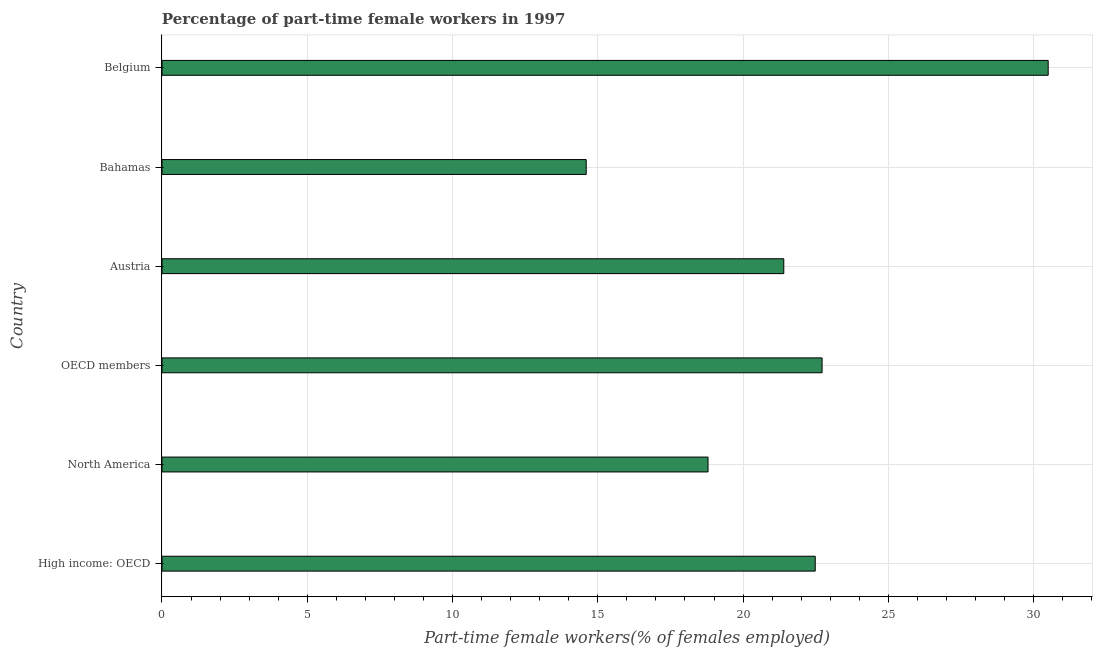Does the graph contain grids?
Give a very brief answer. Yes. What is the title of the graph?
Offer a terse response. Percentage of part-time female workers in 1997. What is the label or title of the X-axis?
Your answer should be very brief. Part-time female workers(% of females employed). What is the percentage of part-time female workers in North America?
Offer a terse response. 18.79. Across all countries, what is the maximum percentage of part-time female workers?
Provide a succinct answer. 30.5. Across all countries, what is the minimum percentage of part-time female workers?
Keep it short and to the point. 14.6. In which country was the percentage of part-time female workers minimum?
Your answer should be compact. Bahamas. What is the sum of the percentage of part-time female workers?
Your answer should be compact. 130.49. What is the difference between the percentage of part-time female workers in Bahamas and North America?
Provide a succinct answer. -4.19. What is the average percentage of part-time female workers per country?
Make the answer very short. 21.75. What is the median percentage of part-time female workers?
Make the answer very short. 21.94. What is the ratio of the percentage of part-time female workers in North America to that in OECD members?
Your answer should be very brief. 0.83. What is the difference between the highest and the second highest percentage of part-time female workers?
Your answer should be compact. 7.78. How many bars are there?
Give a very brief answer. 6. Are all the bars in the graph horizontal?
Your answer should be compact. Yes. How many countries are there in the graph?
Provide a succinct answer. 6. What is the difference between two consecutive major ticks on the X-axis?
Ensure brevity in your answer.  5. Are the values on the major ticks of X-axis written in scientific E-notation?
Ensure brevity in your answer.  No. What is the Part-time female workers(% of females employed) of High income: OECD?
Your response must be concise. 22.48. What is the Part-time female workers(% of females employed) in North America?
Offer a very short reply. 18.79. What is the Part-time female workers(% of females employed) of OECD members?
Give a very brief answer. 22.72. What is the Part-time female workers(% of females employed) in Austria?
Your response must be concise. 21.4. What is the Part-time female workers(% of females employed) in Bahamas?
Provide a succinct answer. 14.6. What is the Part-time female workers(% of females employed) in Belgium?
Offer a very short reply. 30.5. What is the difference between the Part-time female workers(% of females employed) in High income: OECD and North America?
Your answer should be very brief. 3.69. What is the difference between the Part-time female workers(% of females employed) in High income: OECD and OECD members?
Offer a very short reply. -0.24. What is the difference between the Part-time female workers(% of females employed) in High income: OECD and Austria?
Give a very brief answer. 1.08. What is the difference between the Part-time female workers(% of females employed) in High income: OECD and Bahamas?
Offer a very short reply. 7.88. What is the difference between the Part-time female workers(% of females employed) in High income: OECD and Belgium?
Your response must be concise. -8.02. What is the difference between the Part-time female workers(% of females employed) in North America and OECD members?
Offer a very short reply. -3.93. What is the difference between the Part-time female workers(% of females employed) in North America and Austria?
Offer a very short reply. -2.61. What is the difference between the Part-time female workers(% of females employed) in North America and Bahamas?
Your response must be concise. 4.19. What is the difference between the Part-time female workers(% of females employed) in North America and Belgium?
Offer a terse response. -11.71. What is the difference between the Part-time female workers(% of females employed) in OECD members and Austria?
Make the answer very short. 1.32. What is the difference between the Part-time female workers(% of females employed) in OECD members and Bahamas?
Provide a short and direct response. 8.12. What is the difference between the Part-time female workers(% of females employed) in OECD members and Belgium?
Ensure brevity in your answer.  -7.78. What is the difference between the Part-time female workers(% of females employed) in Austria and Bahamas?
Give a very brief answer. 6.8. What is the difference between the Part-time female workers(% of females employed) in Bahamas and Belgium?
Ensure brevity in your answer.  -15.9. What is the ratio of the Part-time female workers(% of females employed) in High income: OECD to that in North America?
Offer a very short reply. 1.2. What is the ratio of the Part-time female workers(% of females employed) in High income: OECD to that in OECD members?
Make the answer very short. 0.99. What is the ratio of the Part-time female workers(% of females employed) in High income: OECD to that in Austria?
Your answer should be compact. 1.05. What is the ratio of the Part-time female workers(% of females employed) in High income: OECD to that in Bahamas?
Keep it short and to the point. 1.54. What is the ratio of the Part-time female workers(% of females employed) in High income: OECD to that in Belgium?
Offer a very short reply. 0.74. What is the ratio of the Part-time female workers(% of females employed) in North America to that in OECD members?
Make the answer very short. 0.83. What is the ratio of the Part-time female workers(% of females employed) in North America to that in Austria?
Provide a succinct answer. 0.88. What is the ratio of the Part-time female workers(% of females employed) in North America to that in Bahamas?
Your answer should be compact. 1.29. What is the ratio of the Part-time female workers(% of females employed) in North America to that in Belgium?
Ensure brevity in your answer.  0.62. What is the ratio of the Part-time female workers(% of females employed) in OECD members to that in Austria?
Give a very brief answer. 1.06. What is the ratio of the Part-time female workers(% of females employed) in OECD members to that in Bahamas?
Keep it short and to the point. 1.56. What is the ratio of the Part-time female workers(% of females employed) in OECD members to that in Belgium?
Offer a very short reply. 0.74. What is the ratio of the Part-time female workers(% of females employed) in Austria to that in Bahamas?
Your answer should be very brief. 1.47. What is the ratio of the Part-time female workers(% of females employed) in Austria to that in Belgium?
Ensure brevity in your answer.  0.7. What is the ratio of the Part-time female workers(% of females employed) in Bahamas to that in Belgium?
Give a very brief answer. 0.48. 